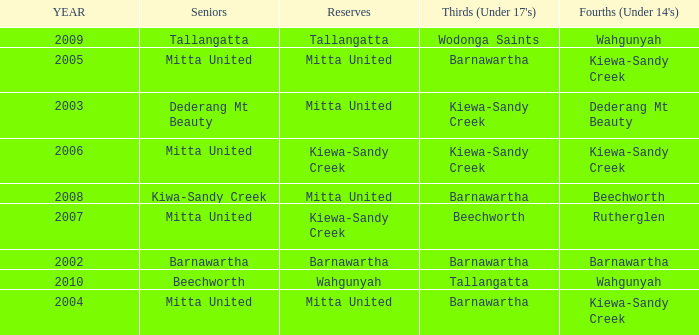Which Fourths (Under 14's) have Seniors of dederang mt beauty? Dederang Mt Beauty. 